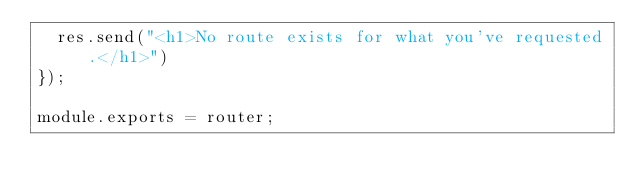<code> <loc_0><loc_0><loc_500><loc_500><_JavaScript_>  res.send("<h1>No route exists for what you've requested.</h1>")
});

module.exports = router;</code> 